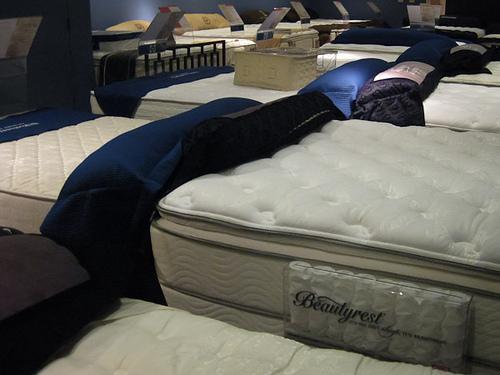How many blue pillows are there?
Give a very brief answer. 4. 